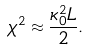Convert formula to latex. <formula><loc_0><loc_0><loc_500><loc_500>\chi ^ { 2 } \approx \frac { \kappa _ { 0 } ^ { 2 } L } { 2 } .</formula> 